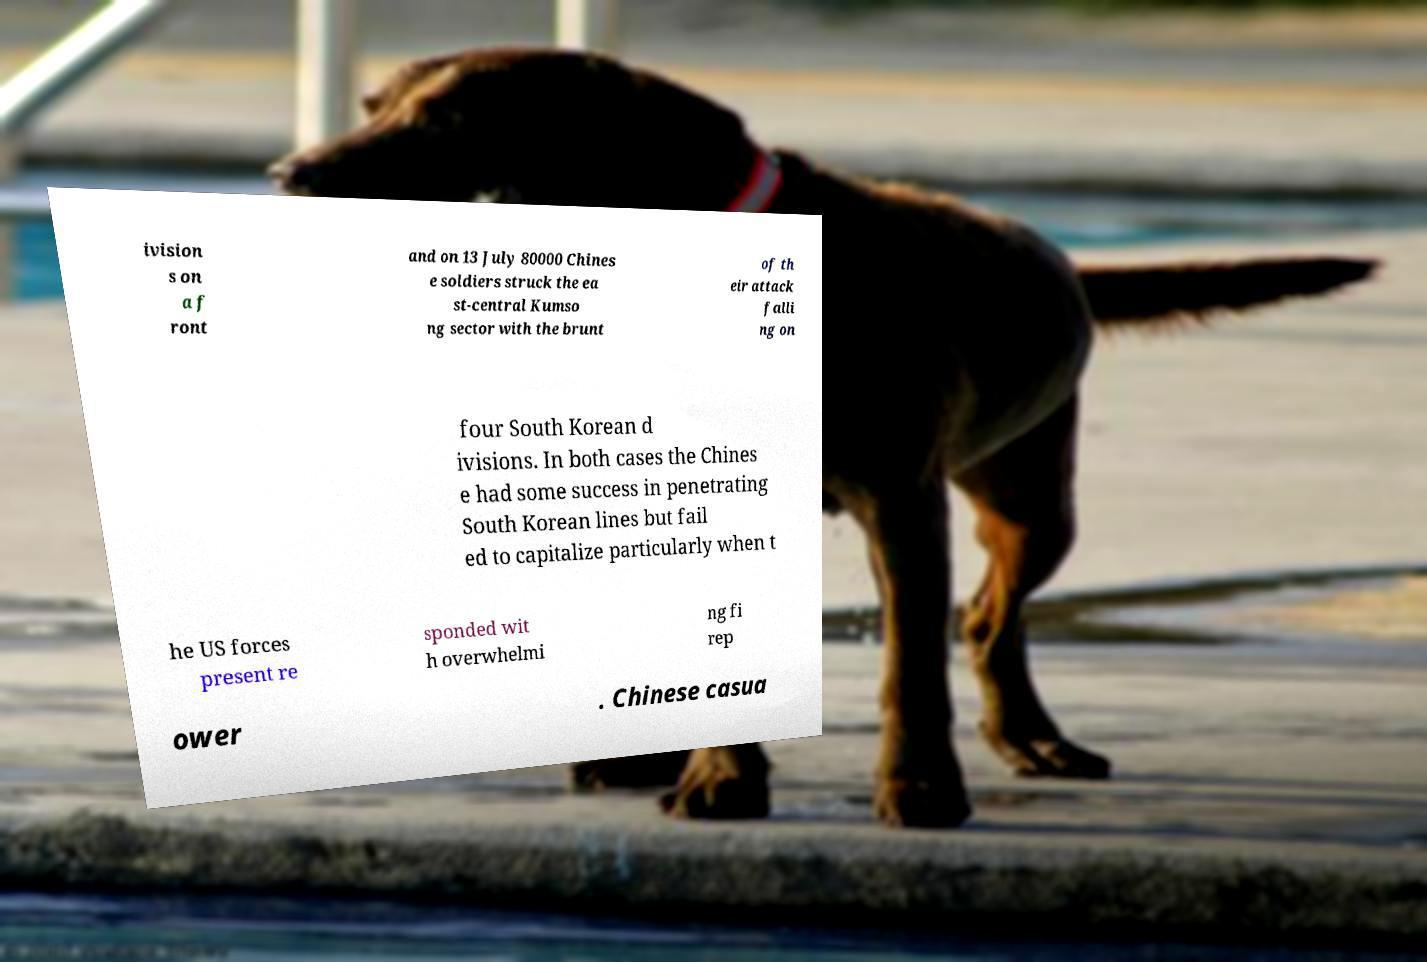I need the written content from this picture converted into text. Can you do that? ivision s on a f ront and on 13 July 80000 Chines e soldiers struck the ea st-central Kumso ng sector with the brunt of th eir attack falli ng on four South Korean d ivisions. In both cases the Chines e had some success in penetrating South Korean lines but fail ed to capitalize particularly when t he US forces present re sponded wit h overwhelmi ng fi rep ower . Chinese casua 